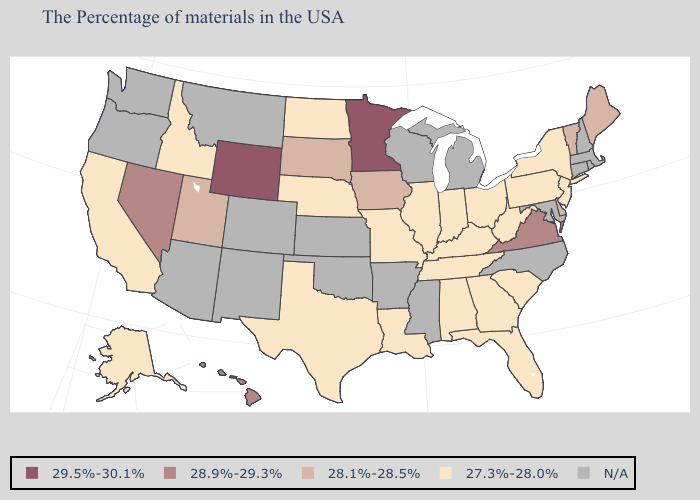Is the legend a continuous bar?
Keep it brief. No. Name the states that have a value in the range 28.1%-28.5%?
Give a very brief answer. Maine, Vermont, Delaware, Iowa, South Dakota, Utah. Name the states that have a value in the range N/A?
Short answer required. Massachusetts, Rhode Island, New Hampshire, Connecticut, Maryland, North Carolina, Michigan, Wisconsin, Mississippi, Arkansas, Kansas, Oklahoma, Colorado, New Mexico, Montana, Arizona, Washington, Oregon. What is the value of Wyoming?
Give a very brief answer. 29.5%-30.1%. Name the states that have a value in the range 29.5%-30.1%?
Short answer required. Minnesota, Wyoming. What is the highest value in states that border Texas?
Be succinct. 27.3%-28.0%. Does the first symbol in the legend represent the smallest category?
Short answer required. No. What is the lowest value in states that border Illinois?
Concise answer only. 27.3%-28.0%. Among the states that border Pennsylvania , does New Jersey have the lowest value?
Be succinct. Yes. What is the value of Virginia?
Be succinct. 28.9%-29.3%. Among the states that border Delaware , which have the highest value?
Answer briefly. New Jersey, Pennsylvania. Among the states that border Wisconsin , does Illinois have the lowest value?
Keep it brief. Yes. What is the highest value in states that border Wisconsin?
Keep it brief. 29.5%-30.1%. 